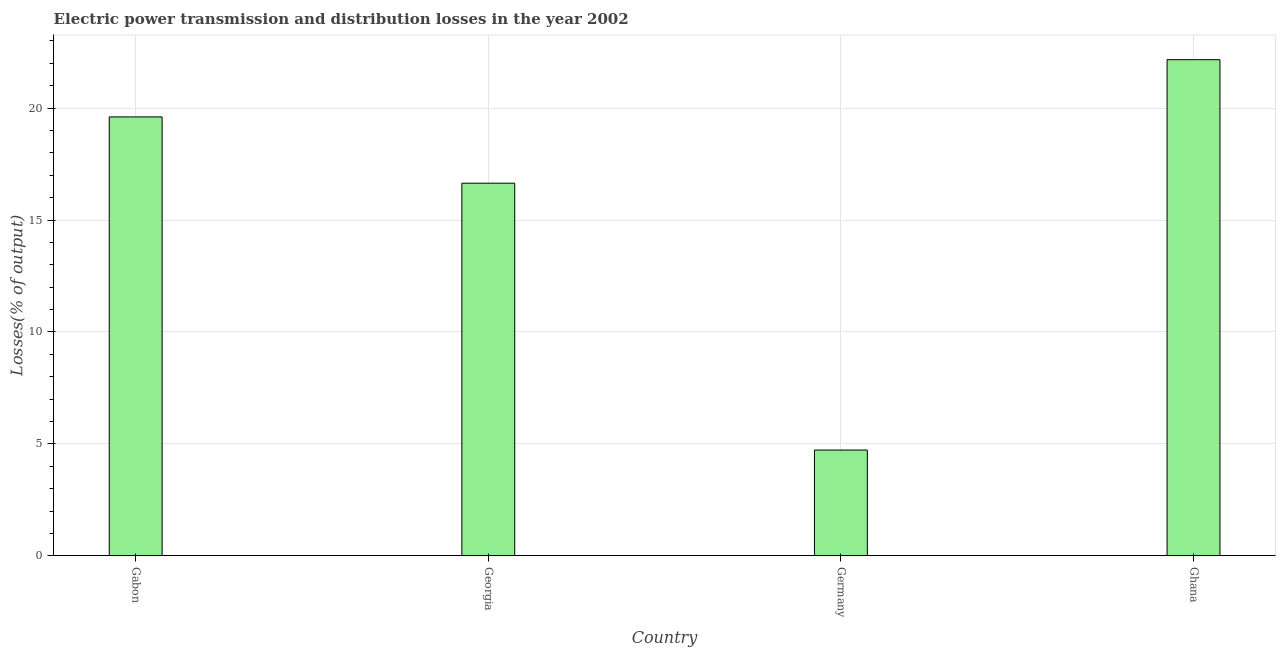What is the title of the graph?
Offer a terse response. Electric power transmission and distribution losses in the year 2002. What is the label or title of the Y-axis?
Keep it short and to the point. Losses(% of output). What is the electric power transmission and distribution losses in Georgia?
Your answer should be very brief. 16.65. Across all countries, what is the maximum electric power transmission and distribution losses?
Your answer should be very brief. 22.16. Across all countries, what is the minimum electric power transmission and distribution losses?
Your answer should be compact. 4.72. In which country was the electric power transmission and distribution losses minimum?
Offer a terse response. Germany. What is the sum of the electric power transmission and distribution losses?
Your answer should be compact. 63.14. What is the difference between the electric power transmission and distribution losses in Gabon and Georgia?
Your response must be concise. 2.96. What is the average electric power transmission and distribution losses per country?
Keep it short and to the point. 15.79. What is the median electric power transmission and distribution losses?
Your response must be concise. 18.13. In how many countries, is the electric power transmission and distribution losses greater than 1 %?
Make the answer very short. 4. What is the ratio of the electric power transmission and distribution losses in Georgia to that in Ghana?
Your answer should be compact. 0.75. Is the electric power transmission and distribution losses in Georgia less than that in Ghana?
Your response must be concise. Yes. Is the difference between the electric power transmission and distribution losses in Georgia and Ghana greater than the difference between any two countries?
Ensure brevity in your answer.  No. What is the difference between the highest and the second highest electric power transmission and distribution losses?
Keep it short and to the point. 2.56. Is the sum of the electric power transmission and distribution losses in Gabon and Germany greater than the maximum electric power transmission and distribution losses across all countries?
Make the answer very short. Yes. What is the difference between the highest and the lowest electric power transmission and distribution losses?
Keep it short and to the point. 17.44. In how many countries, is the electric power transmission and distribution losses greater than the average electric power transmission and distribution losses taken over all countries?
Keep it short and to the point. 3. How many countries are there in the graph?
Give a very brief answer. 4. What is the difference between two consecutive major ticks on the Y-axis?
Your answer should be compact. 5. Are the values on the major ticks of Y-axis written in scientific E-notation?
Keep it short and to the point. No. What is the Losses(% of output) of Gabon?
Provide a succinct answer. 19.61. What is the Losses(% of output) of Georgia?
Provide a short and direct response. 16.65. What is the Losses(% of output) of Germany?
Your answer should be compact. 4.72. What is the Losses(% of output) in Ghana?
Give a very brief answer. 22.16. What is the difference between the Losses(% of output) in Gabon and Georgia?
Your answer should be very brief. 2.96. What is the difference between the Losses(% of output) in Gabon and Germany?
Provide a short and direct response. 14.88. What is the difference between the Losses(% of output) in Gabon and Ghana?
Offer a very short reply. -2.56. What is the difference between the Losses(% of output) in Georgia and Germany?
Make the answer very short. 11.92. What is the difference between the Losses(% of output) in Georgia and Ghana?
Your answer should be very brief. -5.52. What is the difference between the Losses(% of output) in Germany and Ghana?
Ensure brevity in your answer.  -17.44. What is the ratio of the Losses(% of output) in Gabon to that in Georgia?
Provide a succinct answer. 1.18. What is the ratio of the Losses(% of output) in Gabon to that in Germany?
Your response must be concise. 4.15. What is the ratio of the Losses(% of output) in Gabon to that in Ghana?
Offer a very short reply. 0.89. What is the ratio of the Losses(% of output) in Georgia to that in Germany?
Keep it short and to the point. 3.52. What is the ratio of the Losses(% of output) in Georgia to that in Ghana?
Ensure brevity in your answer.  0.75. What is the ratio of the Losses(% of output) in Germany to that in Ghana?
Offer a very short reply. 0.21. 